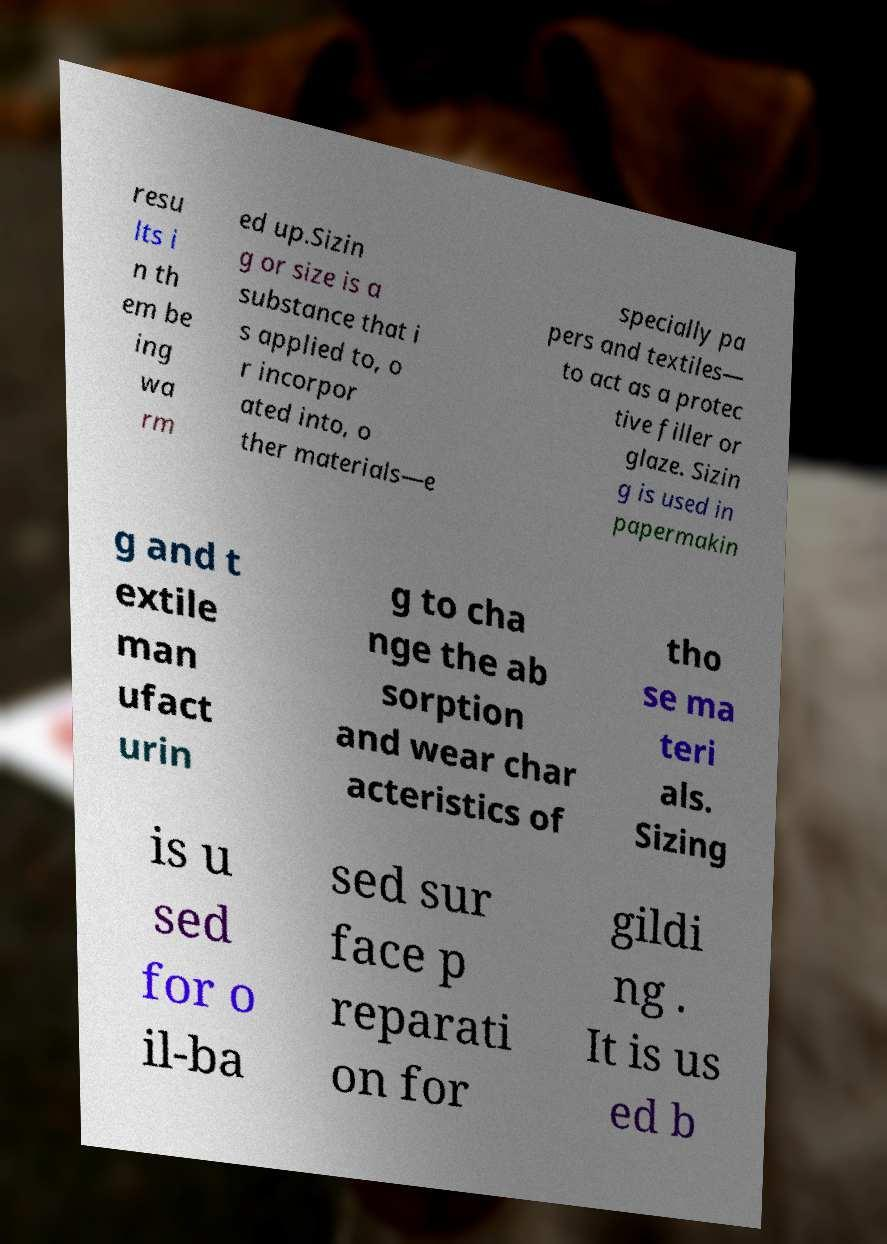I need the written content from this picture converted into text. Can you do that? resu lts i n th em be ing wa rm ed up.Sizin g or size is a substance that i s applied to, o r incorpor ated into, o ther materials—e specially pa pers and textiles— to act as a protec tive filler or glaze. Sizin g is used in papermakin g and t extile man ufact urin g to cha nge the ab sorption and wear char acteristics of tho se ma teri als. Sizing is u sed for o il-ba sed sur face p reparati on for gildi ng . It is us ed b 